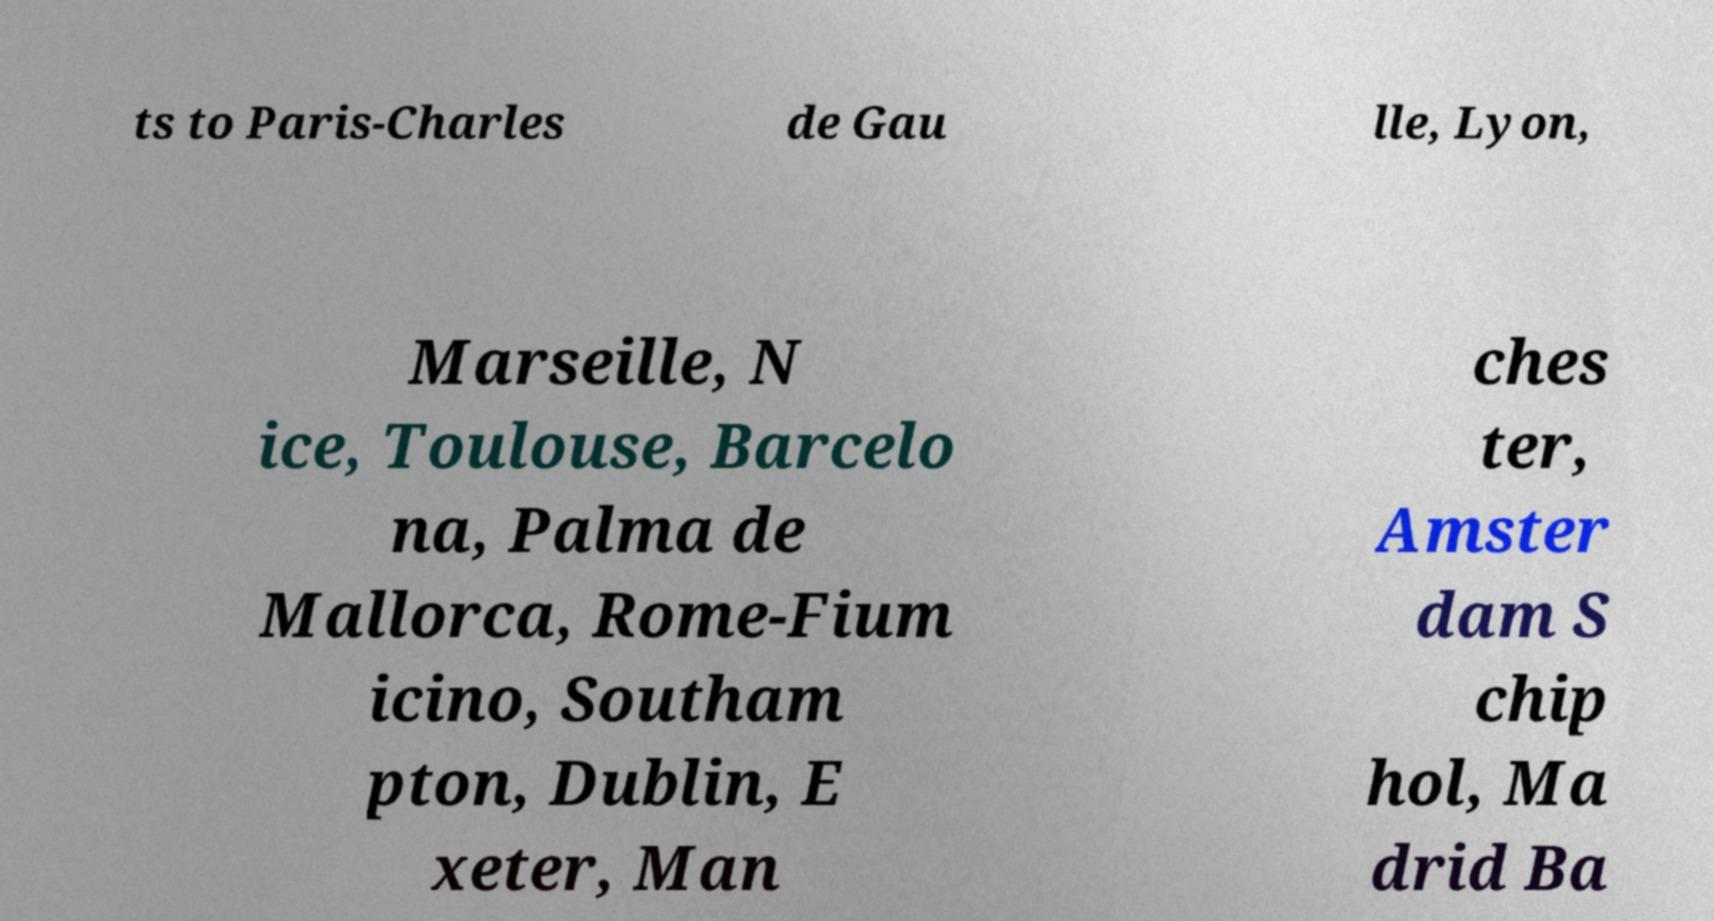I need the written content from this picture converted into text. Can you do that? ts to Paris-Charles de Gau lle, Lyon, Marseille, N ice, Toulouse, Barcelo na, Palma de Mallorca, Rome-Fium icino, Southam pton, Dublin, E xeter, Man ches ter, Amster dam S chip hol, Ma drid Ba 